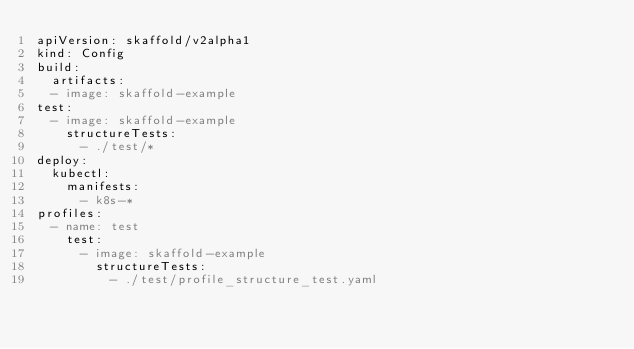<code> <loc_0><loc_0><loc_500><loc_500><_YAML_>apiVersion: skaffold/v2alpha1
kind: Config
build:
  artifacts:
  - image: skaffold-example
test:
  - image: skaffold-example
    structureTests:
      - ./test/*
deploy:
  kubectl:
    manifests:
      - k8s-*
profiles:
  - name: test
    test:
      - image: skaffold-example
        structureTests:
          - ./test/profile_structure_test.yaml
</code> 